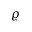<formula> <loc_0><loc_0><loc_500><loc_500>\varrho</formula> 